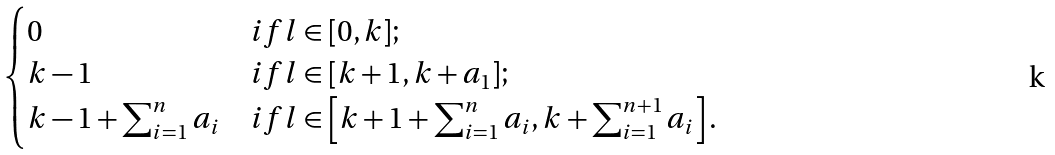<formula> <loc_0><loc_0><loc_500><loc_500>\begin{cases} 0 & i f l \in [ 0 , k ] ; \\ k - 1 & i f l \in [ k + 1 , k + a _ { 1 } ] ; \\ k - 1 + \sum _ { i = 1 } ^ { n } a _ { i } & i f l \in \left [ k + 1 + \sum _ { i = 1 } ^ { n } a _ { i } , k + \sum _ { i = 1 } ^ { n + 1 } a _ { i } \right ] . \\ \end{cases}</formula> 